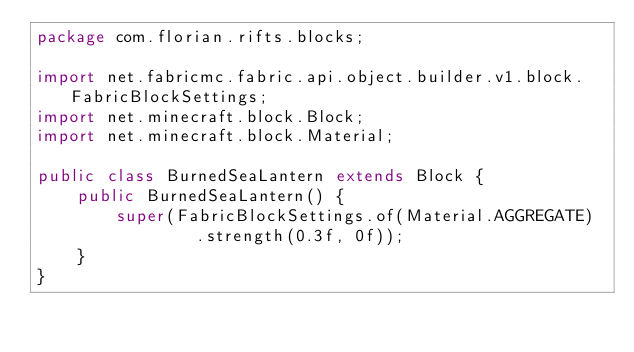<code> <loc_0><loc_0><loc_500><loc_500><_Java_>package com.florian.rifts.blocks;

import net.fabricmc.fabric.api.object.builder.v1.block.FabricBlockSettings;
import net.minecraft.block.Block;
import net.minecraft.block.Material;

public class BurnedSeaLantern extends Block {
    public BurnedSeaLantern() {
        super(FabricBlockSettings.of(Material.AGGREGATE)
                .strength(0.3f, 0f));
    }
}</code> 